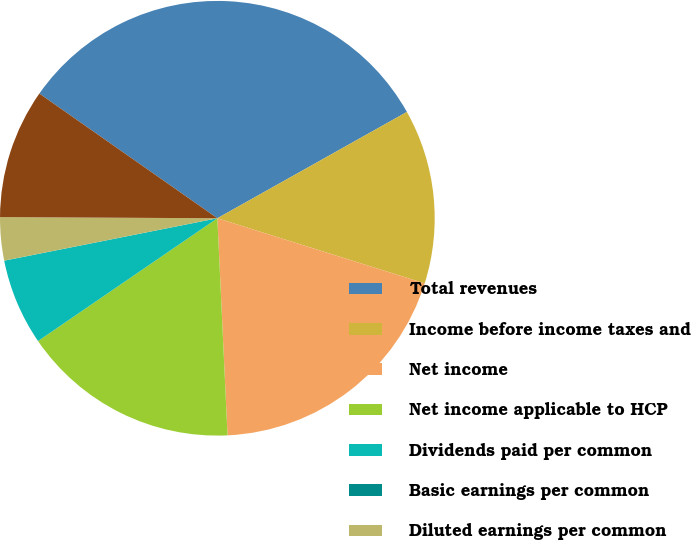Convert chart. <chart><loc_0><loc_0><loc_500><loc_500><pie_chart><fcel>Total revenues<fcel>Income before income taxes and<fcel>Net income<fcel>Net income applicable to HCP<fcel>Dividends paid per common<fcel>Basic earnings per common<fcel>Diluted earnings per common<fcel>Total discontinued operations<nl><fcel>32.14%<fcel>12.98%<fcel>19.41%<fcel>16.19%<fcel>6.43%<fcel>0.0%<fcel>3.21%<fcel>9.64%<nl></chart> 